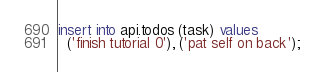<code> <loc_0><loc_0><loc_500><loc_500><_SQL_>insert into api.todos (task) values
  ('finish tutorial 0'), ('pat self on back');
</code> 